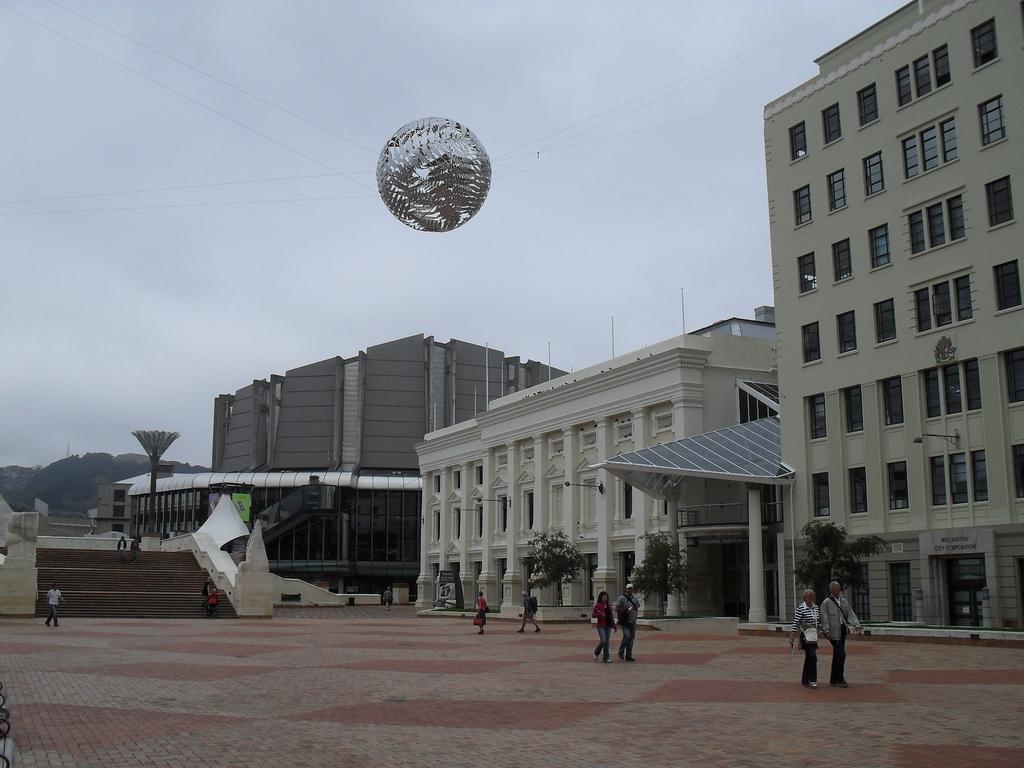Could you give a brief overview of what you see in this image? In this picture I can see there are few people walking and there are few buildings at right side and there are few stairs and there is a ball and it is attached with ropes, there are a few stairs at left side, there is a mountain in the backdrop and the sky is cloudy. 